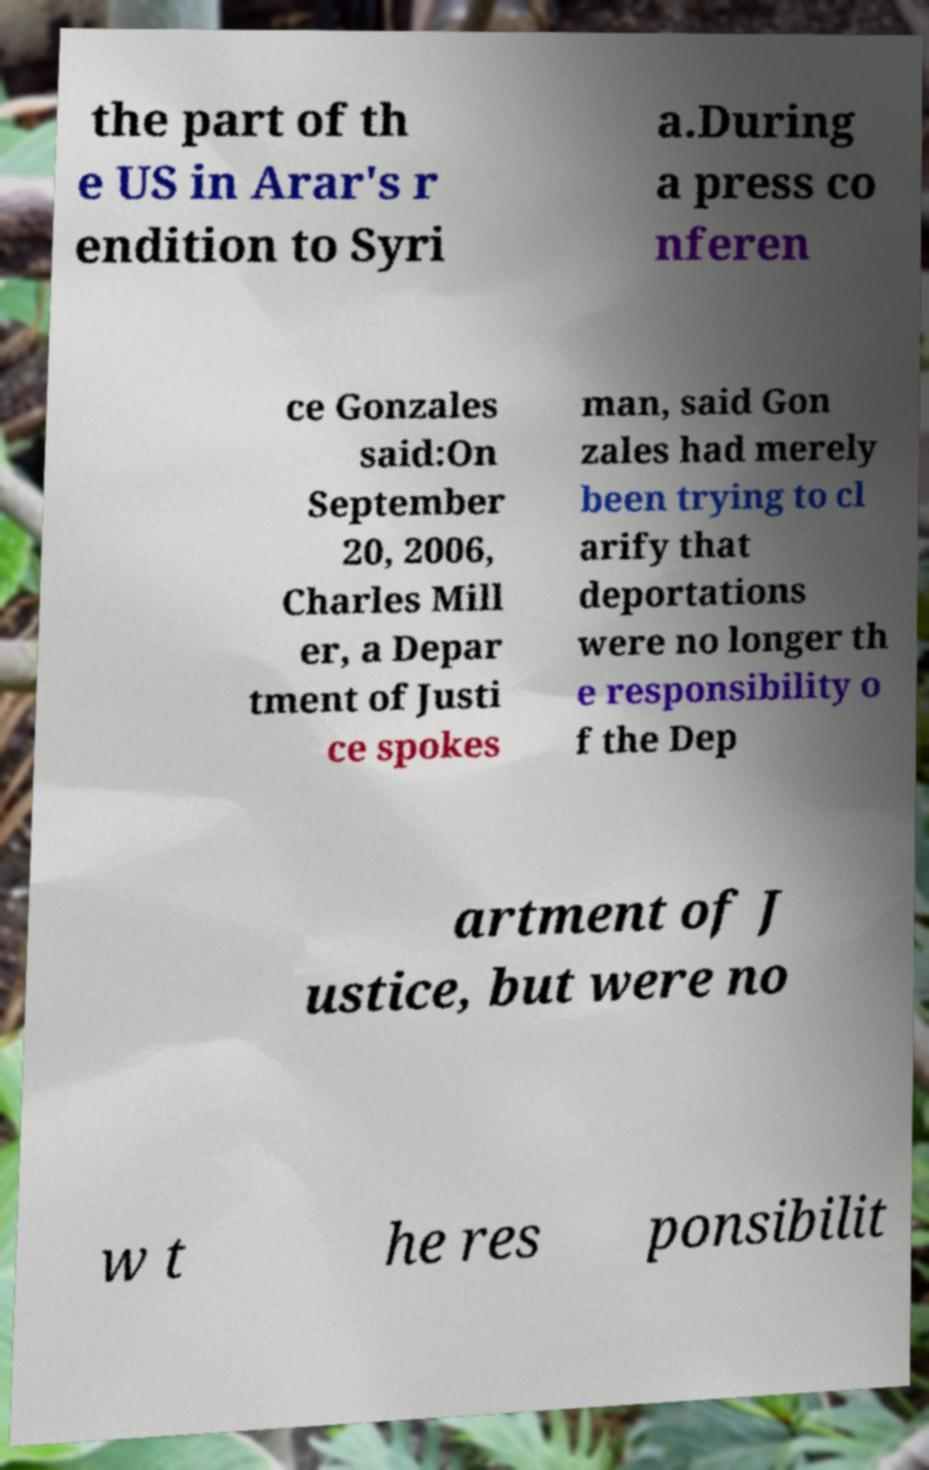For documentation purposes, I need the text within this image transcribed. Could you provide that? the part of th e US in Arar's r endition to Syri a.During a press co nferen ce Gonzales said:On September 20, 2006, Charles Mill er, a Depar tment of Justi ce spokes man, said Gon zales had merely been trying to cl arify that deportations were no longer th e responsibility o f the Dep artment of J ustice, but were no w t he res ponsibilit 